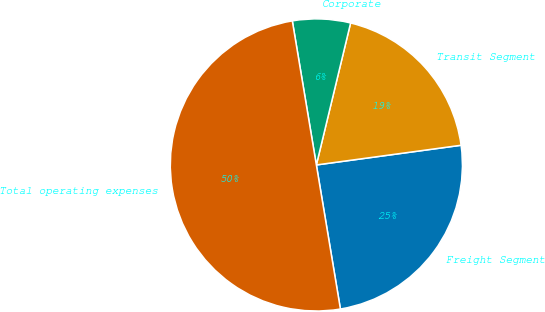<chart> <loc_0><loc_0><loc_500><loc_500><pie_chart><fcel>Freight Segment<fcel>Transit Segment<fcel>Corporate<fcel>Total operating expenses<nl><fcel>24.52%<fcel>19.08%<fcel>6.4%<fcel>50.0%<nl></chart> 